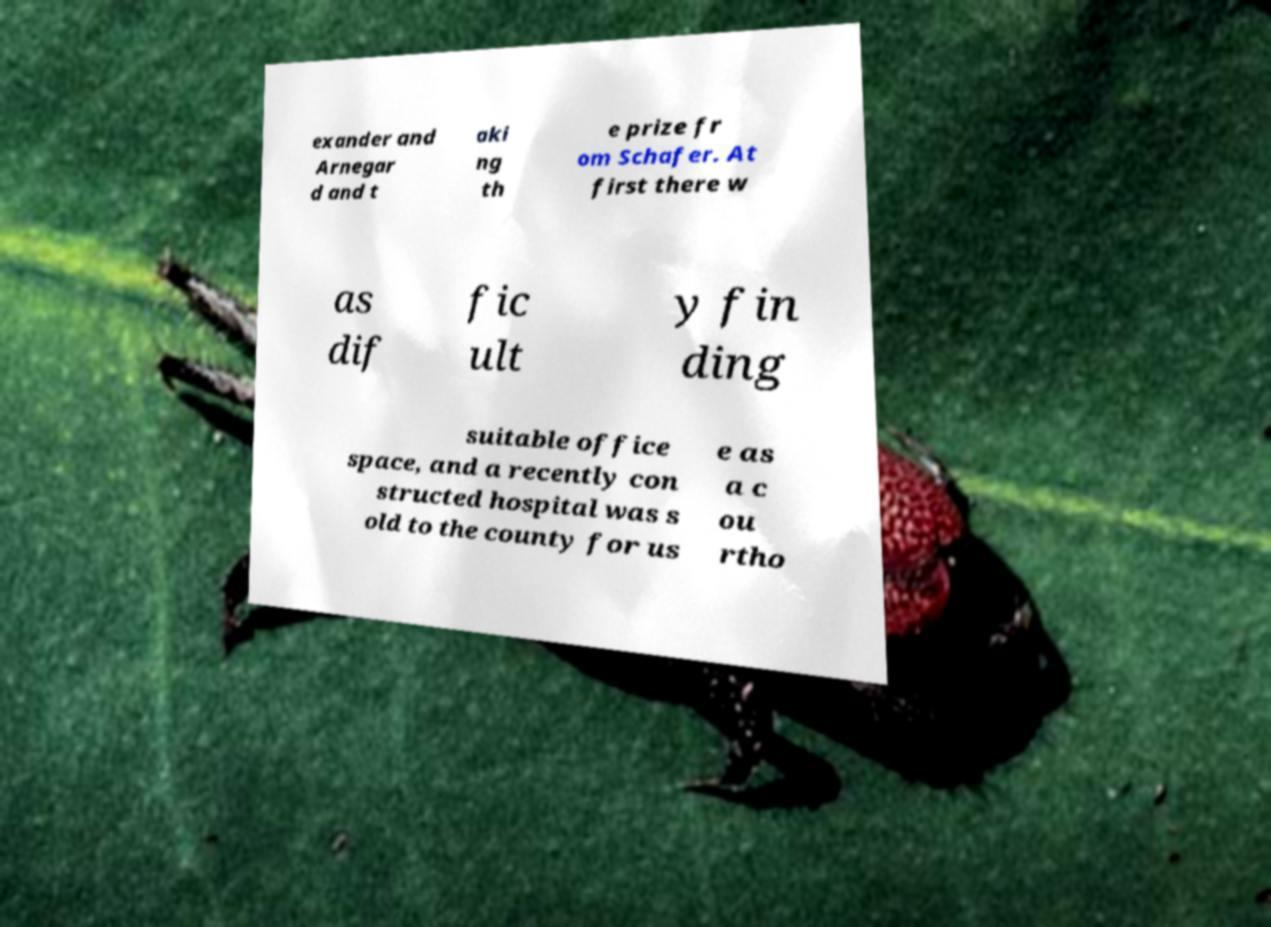Could you assist in decoding the text presented in this image and type it out clearly? exander and Arnegar d and t aki ng th e prize fr om Schafer. At first there w as dif fic ult y fin ding suitable office space, and a recently con structed hospital was s old to the county for us e as a c ou rtho 